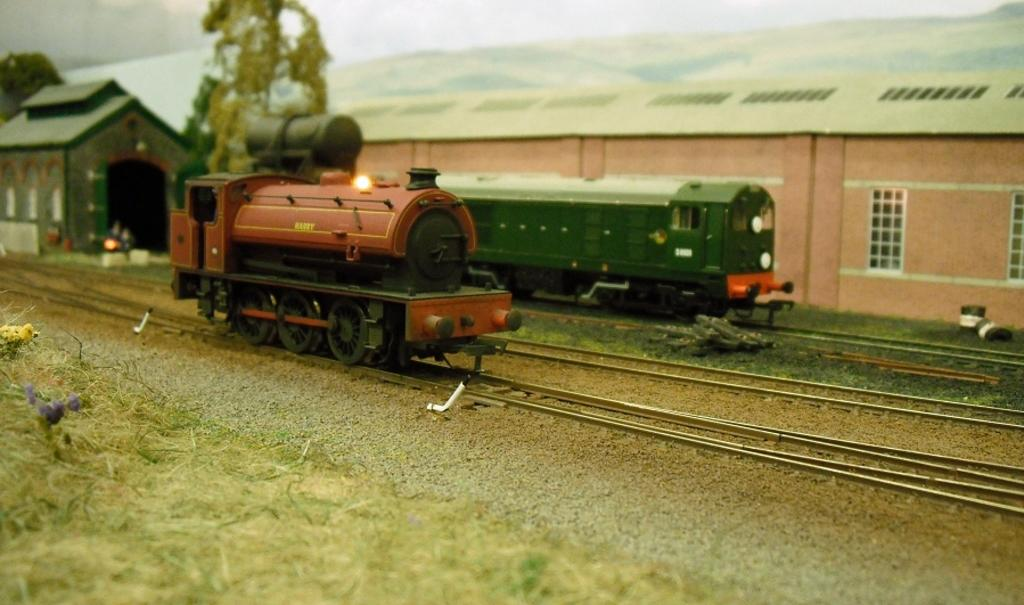What type of vehicles are present in the image? There are scale model trains in the image. What else can be seen in the image besides the trains? There are houses and railway tracks in the image. Can you describe the objects in the image? There are some objects in the image, but their specific nature is not mentioned in the facts. What type of vegetation is present on the left side of the trains? There is grass on the left side of the trains. How do the mice interact with the snow in the image? There are no mice or snow present in the image. What type of wash is used to clean the trains in the image? There is no mention of washing or cleaning the trains in the image. 